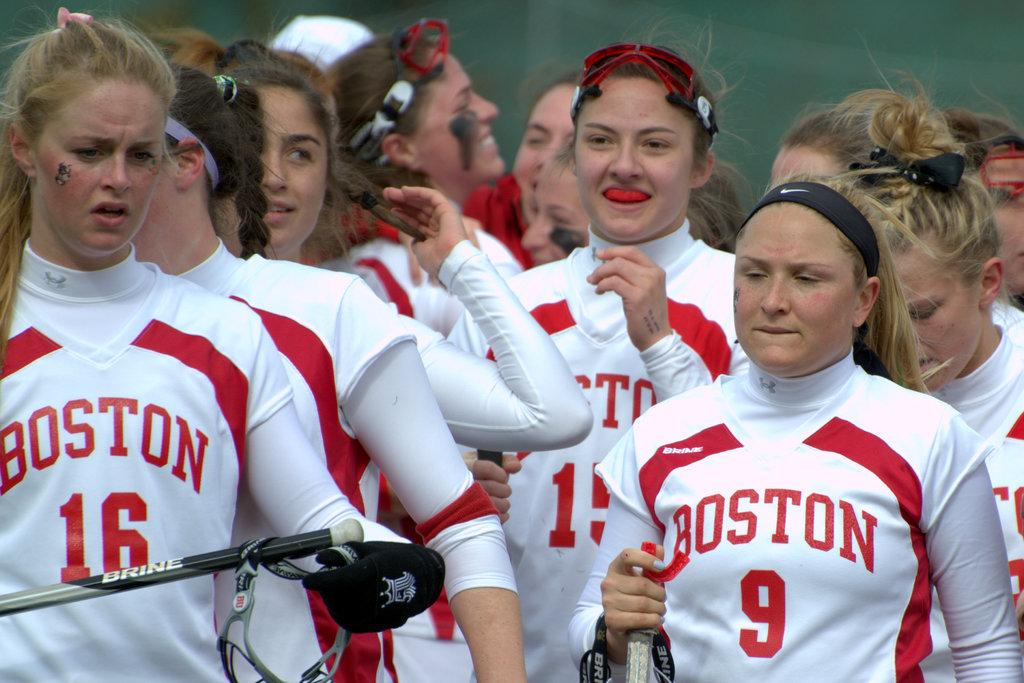<image>
Offer a succinct explanation of the picture presented. Female team members from Boston have red and white uniforms. 